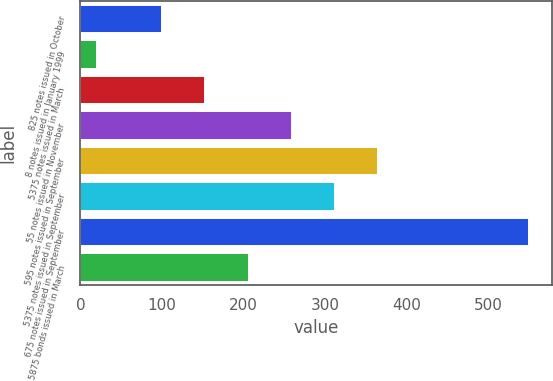Convert chart to OTSL. <chart><loc_0><loc_0><loc_500><loc_500><bar_chart><fcel>825 notes issued in October<fcel>8 notes issued in January 1999<fcel>5375 notes issued in March<fcel>55 notes issued in November<fcel>595 notes issued in September<fcel>5375 notes issued in September<fcel>675 notes issued in September<fcel>5875 bonds issued in March<nl><fcel>100<fcel>20<fcel>153<fcel>259<fcel>365<fcel>312<fcel>550<fcel>206<nl></chart> 